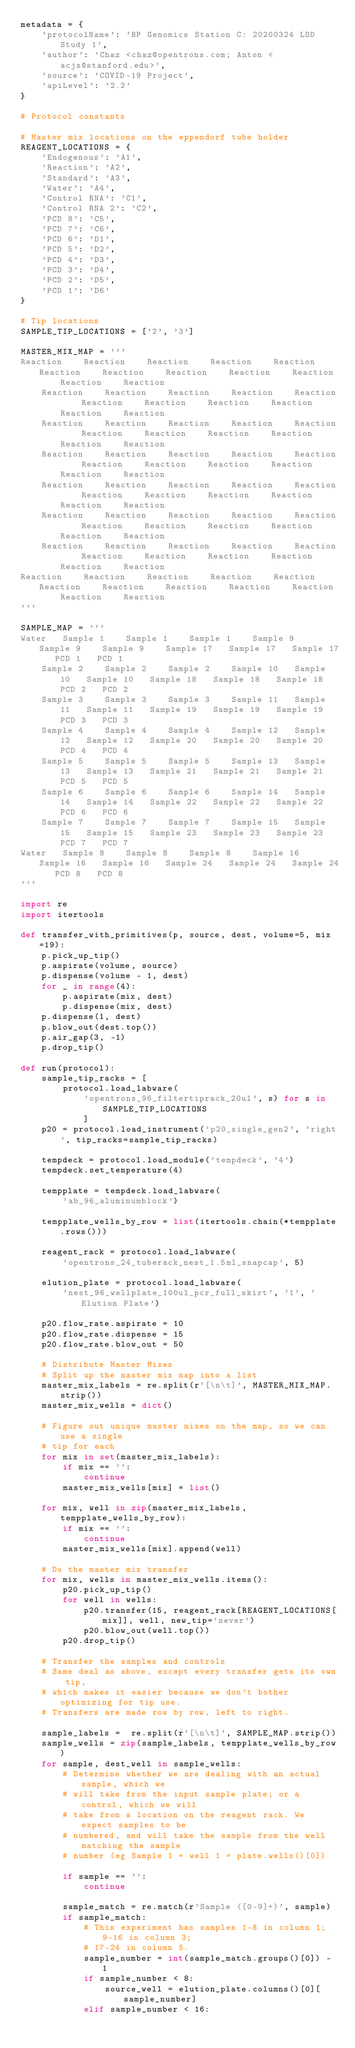<code> <loc_0><loc_0><loc_500><loc_500><_Python_>metadata = {
    'protocolName': 'BP Genomics Station C: 20200324 LOD Study 1',
    'author': 'Chaz <chaz@opentrons.com; Anton <acjs@stanford.edu>',
    'source': 'COVID-19 Project',
    'apiLevel': '2.2'
}

# Protocol constants

# Master mix locations on the eppendorf tube holder
REAGENT_LOCATIONS = {
    'Endogenous': 'A1',
    'Reaction': 'A2',
    'Standard': 'A3',
    'Water': 'A4',
    'Control RNA': 'C1',
    'Control RNA 2': 'C2',
    'PCD 8': 'C5',
    'PCD 7': 'C6',
    'PCD 6': 'D1',
    'PCD 5': 'D2',
    'PCD 4': 'D3',
    'PCD 3': 'D4',
    'PCD 2': 'D5',
    'PCD 1': 'D6'
}

# Tip locations
SAMPLE_TIP_LOCATIONS = ['2', '3']

MASTER_MIX_MAP = '''
Reaction	Reaction	Reaction	Reaction	Reaction	Reaction	Reaction	Reaction	Reaction	Reaction	Reaction	Reaction
	Reaction	Reaction	Reaction	Reaction	Reaction	Reaction	Reaction	Reaction	Reaction	Reaction	Reaction
	Reaction	Reaction	Reaction	Reaction	Reaction	Reaction	Reaction	Reaction	Reaction	Reaction	Reaction
	Reaction	Reaction	Reaction	Reaction	Reaction	Reaction	Reaction	Reaction	Reaction	Reaction	Reaction
	Reaction	Reaction	Reaction	Reaction	Reaction	Reaction	Reaction	Reaction	Reaction	Reaction	Reaction
	Reaction	Reaction	Reaction	Reaction	Reaction	Reaction	Reaction	Reaction	Reaction	Reaction	Reaction
	Reaction	Reaction	Reaction	Reaction	Reaction	Reaction	Reaction	Reaction	Reaction	Reaction	Reaction
Reaction	Reaction	Reaction	Reaction	Reaction	Reaction	Reaction	Reaction	Reaction	Reaction	Reaction	Reaction
'''

SAMPLE_MAP = '''
Water	Sample 1	Sample 1	Sample 1	Sample 9	Sample 9	Sample 9	Sample 17	Sample 17	Sample 17	PCD 1	PCD 1
	Sample 2	Sample 2	Sample 2	Sample 10	Sample 10	Sample 10	Sample 18	Sample 18	Sample 18	PCD 2	PCD 2
	Sample 3	Sample 3	Sample 3	Sample 11	Sample 11	Sample 11	Sample 19	Sample 19	Sample 19	PCD 3	PCD 3
	Sample 4	Sample 4	Sample 4	Sample 12	Sample 12	Sample 12	Sample 20	Sample 20	Sample 20	PCD 4	PCD 4
	Sample 5	Sample 5	Sample 5	Sample 13	Sample 13	Sample 13	Sample 21	Sample 21	Sample 21	PCD 5	PCD 5
	Sample 6	Sample 6	Sample 6	Sample 14	Sample 14	Sample 14	Sample 22	Sample 22	Sample 22	PCD 6	PCD 6
	Sample 7	Sample 7	Sample 7	Sample 15	Sample 15	Sample 15	Sample 23	Sample 23	Sample 23	PCD 7	PCD 7
Water	Sample 8	Sample 8	Sample 8	Sample 16	Sample 16	Sample 16	Sample 24	Sample 24	Sample 24	PCD 8	PCD 8
'''

import re
import itertools

def transfer_with_primitives(p, source, dest, volume=5, mix=19):
    p.pick_up_tip()
    p.aspirate(volume, source)
    p.dispense(volume - 1, dest)
    for _ in range(4):
        p.aspirate(mix, dest)
        p.dispense(mix, dest)
    p.dispense(1, dest)
    p.blow_out(dest.top())
    p.air_gap(3, -1)
    p.drop_tip()

def run(protocol):
    sample_tip_racks = [
        protocol.load_labware(
            'opentrons_96_filtertiprack_20ul', s) for s in SAMPLE_TIP_LOCATIONS
            ]
    p20 = protocol.load_instrument('p20_single_gen2', 'right', tip_racks=sample_tip_racks)

    tempdeck = protocol.load_module('tempdeck', '4')
    tempdeck.set_temperature(4)

    tempplate = tempdeck.load_labware(
        'ab_96_aluminumblock')

    tempplate_wells_by_row = list(itertools.chain(*tempplate.rows()))

    reagent_rack = protocol.load_labware(
        'opentrons_24_tuberack_nest_1.5ml_snapcap', 5)

    elution_plate = protocol.load_labware(
        'nest_96_wellplate_100ul_pcr_full_skirt', '1', 'Elution Plate')

    p20.flow_rate.aspirate = 10
    p20.flow_rate.dispense = 15
    p20.flow_rate.blow_out = 50

    # Distribute Master Mixes
    # Split up the master mix map into a list
    master_mix_labels = re.split(r'[\n\t]', MASTER_MIX_MAP.strip())
    master_mix_wells = dict()

    # Figure out unique master mixes on the map, so we can use a single
    # tip for each
    for mix in set(master_mix_labels):
        if mix == '':
            continue
        master_mix_wells[mix] = list()

    for mix, well in zip(master_mix_labels, tempplate_wells_by_row):
        if mix == '':
            continue
        master_mix_wells[mix].append(well)

    # Do the master mix transfer
    for mix, wells in master_mix_wells.items():
        p20.pick_up_tip()
        for well in wells:
            p20.transfer(15, reagent_rack[REAGENT_LOCATIONS[mix]], well, new_tip='never')
            p20.blow_out(well.top())
        p20.drop_tip()

    # Transfer the samples and controls
    # Same deal as above, except every transfer gets its own tip,
    # which makes it easier because we don't bother optimizing for tip use.
    # Transfers are made row by row, left to right.

    sample_labels =  re.split(r'[\n\t]', SAMPLE_MAP.strip())
    sample_wells = zip(sample_labels, tempplate_wells_by_row)
    for sample, dest_well in sample_wells:
        # Determine whether we are dealing with an actual sample, which we
        # will take from the input sample plate; or a control, which we will
        # take from a location on the reagent rack. We expect samples to be
        # numbered, and will take the sample from the well matching the sample
        # number (eg Sample 1 = well 1 = plate.wells()[0])

        if sample == '':
            continue

        sample_match = re.match(r'Sample ([0-9]+)', sample)
        if sample_match:
            # This experiment has samples 1-8 in column 1; 9-16 in column 3;
            # 17-24 in column 5.
            sample_number = int(sample_match.groups()[0]) - 1
            if sample_number < 8:
                source_well = elution_plate.columns()[0][sample_number]
            elif sample_number < 16:</code> 